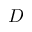<formula> <loc_0><loc_0><loc_500><loc_500>D</formula> 